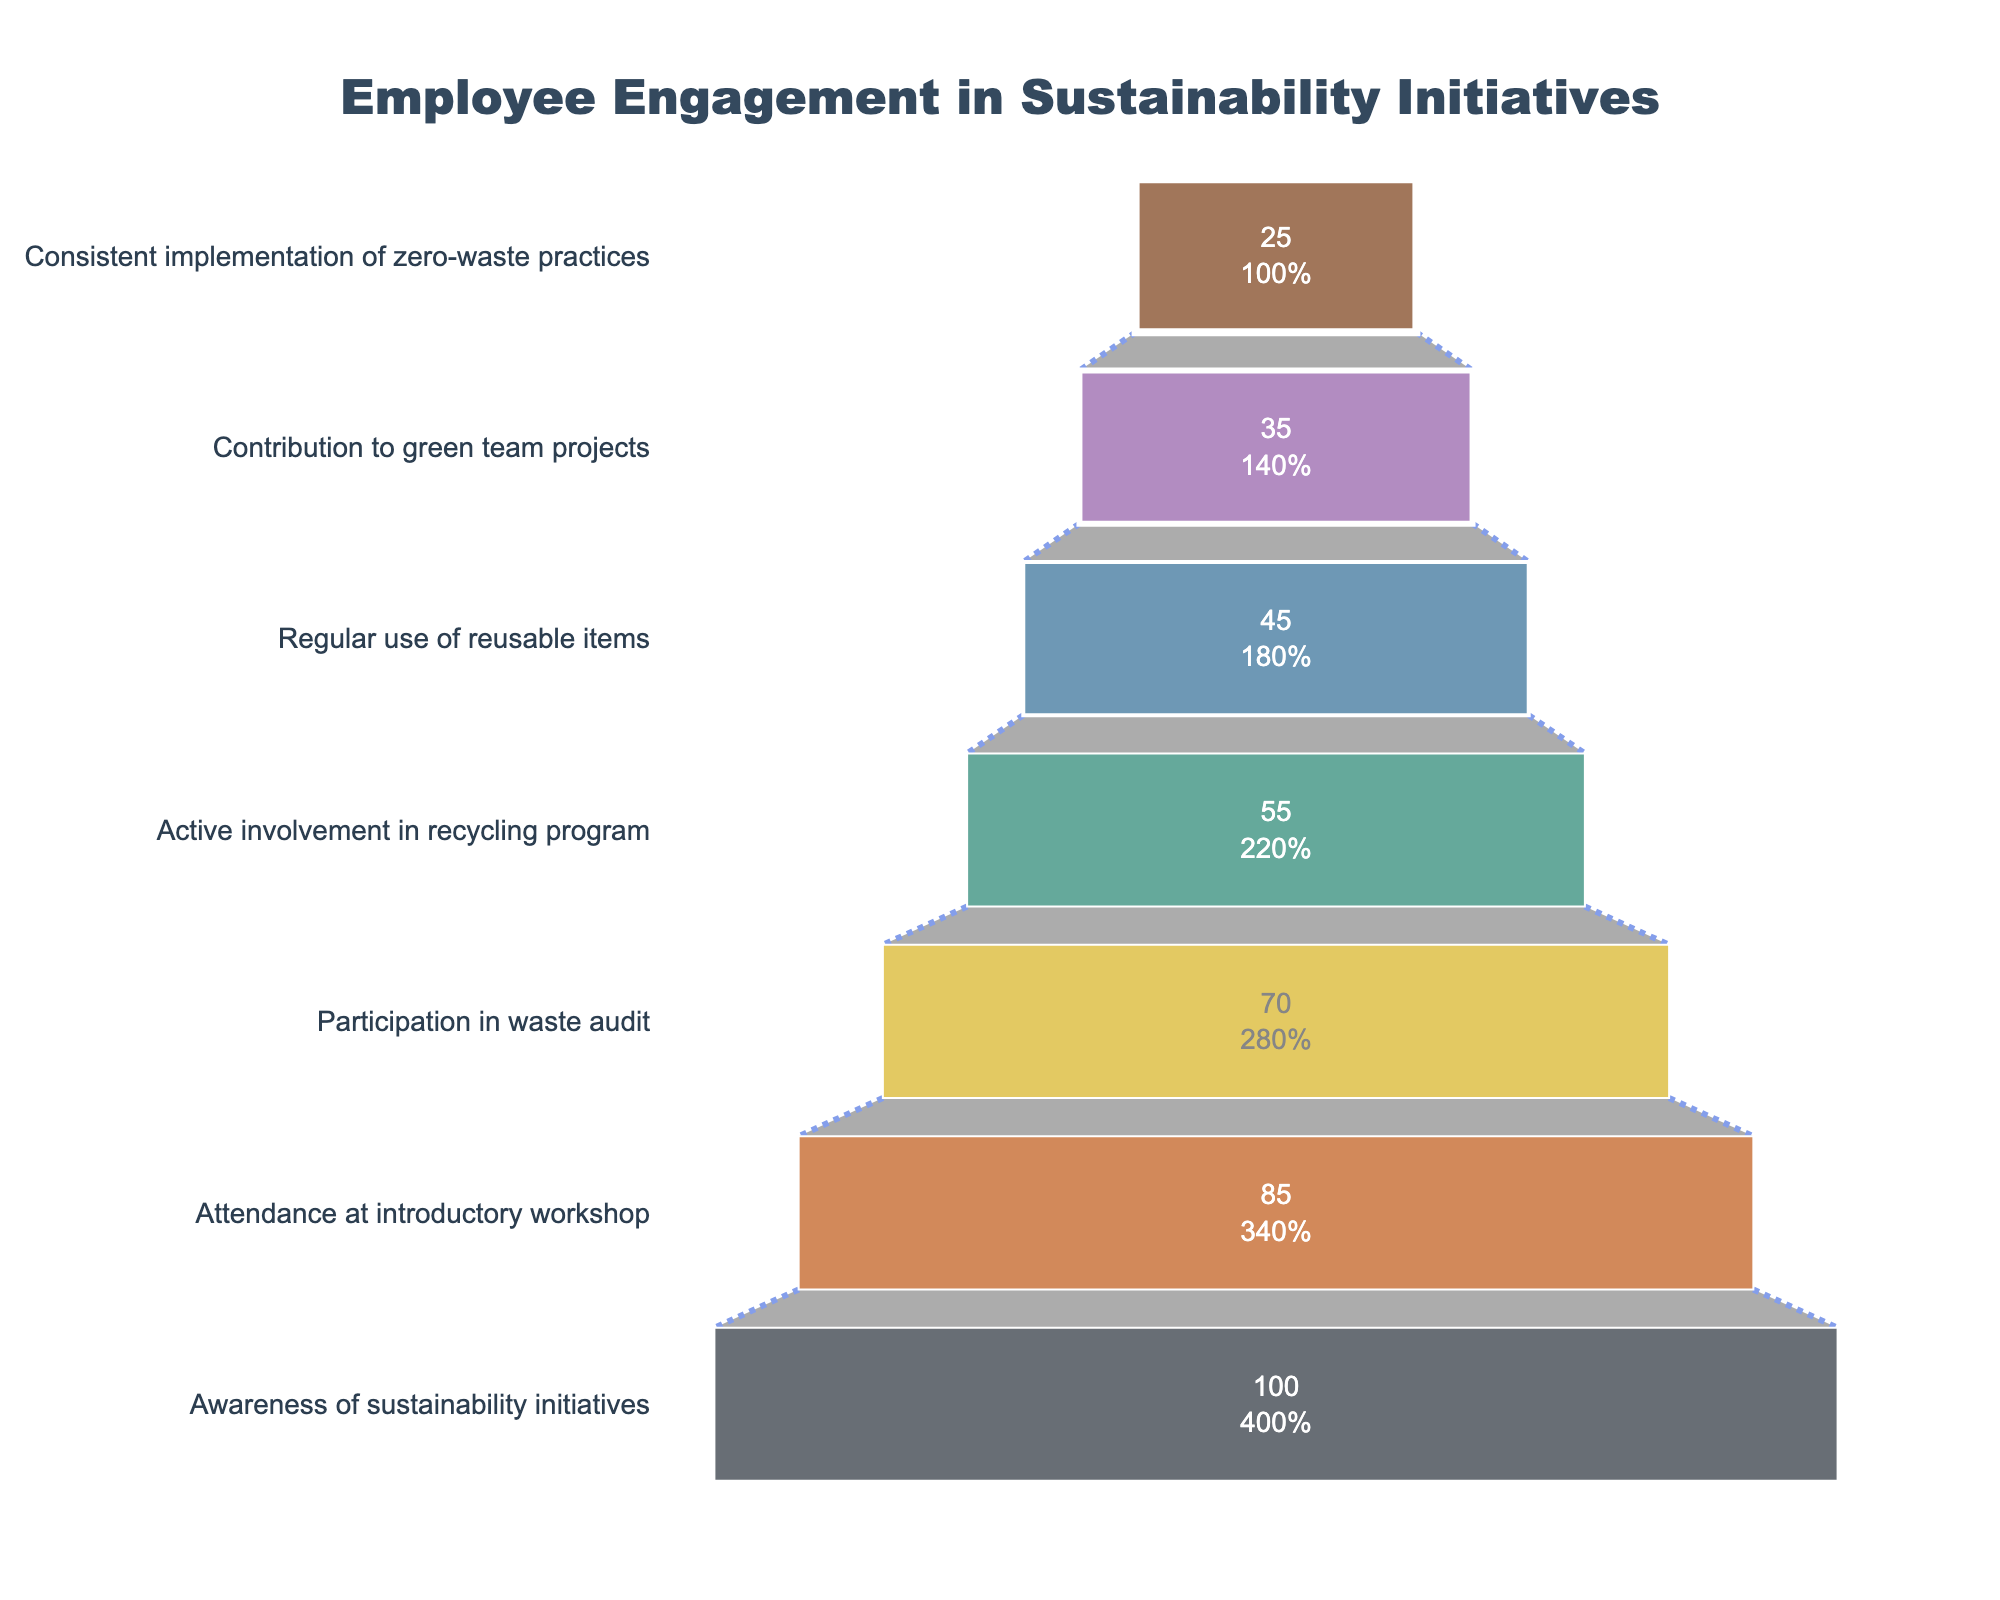What is the title of the figure? The title of the figure is displayed prominently at the top of the plot in larger font size, with the text centered.
Answer: Employee Engagement in Sustainability Initiatives How many stages are there in the funnel chart? The number of stages can be counted along the y-axis of the funnel chart. Each unique label signifies a different stage.
Answer: Seven How many employees are consistently implementing zero-waste practices? Look for the stage labeled "Consistent implementation of zero-waste practices" and check the associated employee count next to it.
Answer: 25 What is the percentage of employees who regularly use reusable items out of those who are aware of sustainability initiatives? First, identify the employee counts for both stages. Then, use the formula: (count of employees regularly using reusable items / count of employees aware of sustainability initiatives) * 100. So, (45 / 100) * 100 = 45%.
Answer: 45% What stage has the highest level of employee engagement? The highest level corresponds to the largest section at the top of the funnel chart.
Answer: Awareness of sustainability initiatives How many more employees attended the introductory workshop compared to those actively involved in the recycling program? Identify the employee counts for both stages and subtract the number for the recycling program stage from the workshop stage. 85 - 55 = 30
Answer: 30 Which stage saw the largest drop in employee numbers compared to the previous stage? Compare the drop in employees between consecutive stages; the largest numerical difference will indicate the biggest drop.
Answer: Attendance at introductory workshop to Participation in waste audit What percentage of the initial employees (aware of sustainability initiatives) are contributing to green team projects? First, find the numbers of the initial employees and those contributing to green team projects. Use the formula: (count of employees contributing to green team projects / count of employees aware of sustainability initiatives) * 100. (35 / 100) * 100 = 35%.
Answer: 35% How many stages have fewer than 50 employees engaged? Count the number of stages shown on the funnel chart where the employee count is less than 50.
Answer: Four At what stage does employee engagement drop below 50% of those who attended the introductory workshop? First, find 50% of employees who attended the introductory workshop (85 * 0.5 = 42.5). Then, identify the first stage where the employee count falls below this number.
Answer: Regular use of reusable items 